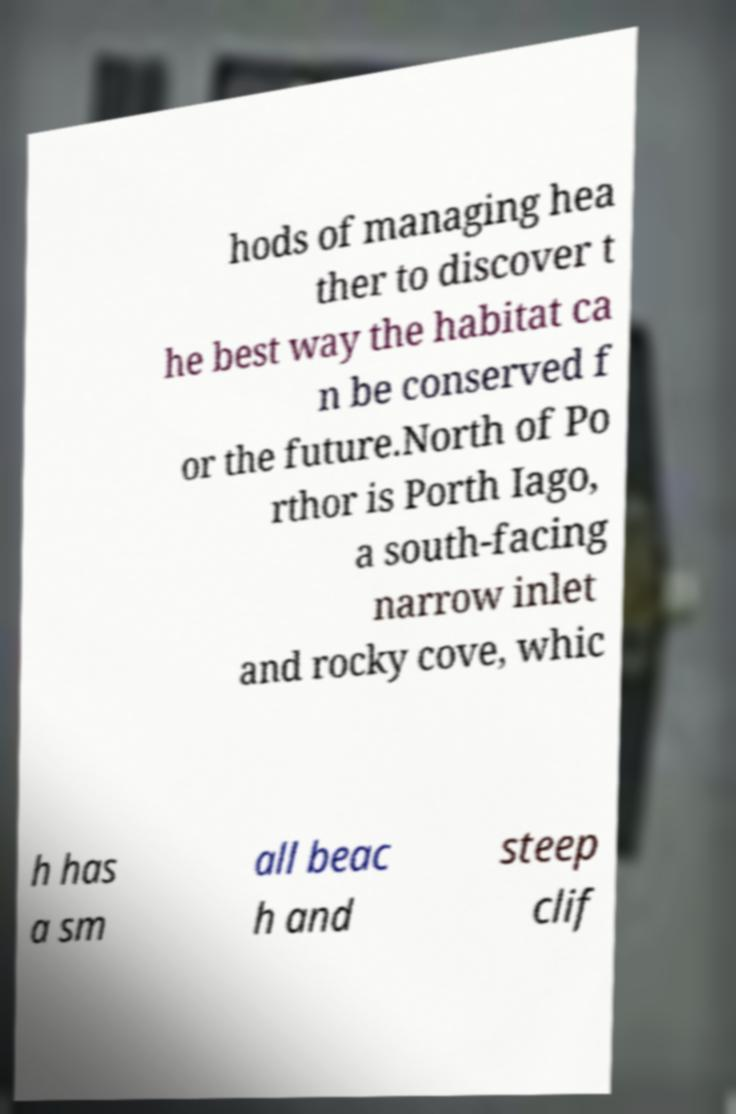Could you assist in decoding the text presented in this image and type it out clearly? hods of managing hea ther to discover t he best way the habitat ca n be conserved f or the future.North of Po rthor is Porth Iago, a south-facing narrow inlet and rocky cove, whic h has a sm all beac h and steep clif 